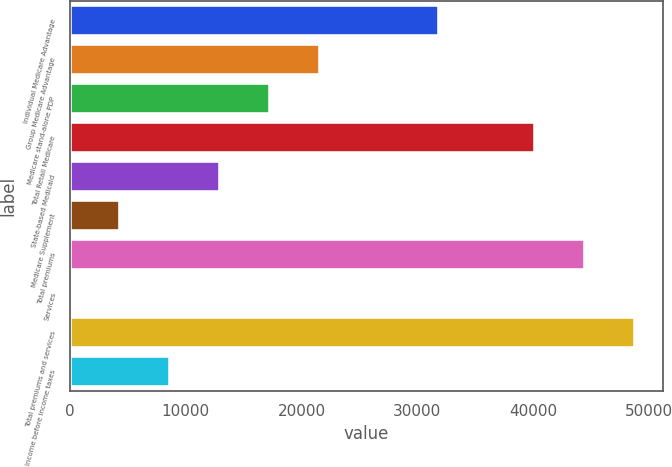Convert chart to OTSL. <chart><loc_0><loc_0><loc_500><loc_500><bar_chart><fcel>Individual Medicare Advantage<fcel>Group Medicare Advantage<fcel>Medicare stand-alone PDP<fcel>Total Retail Medicare<fcel>State-based Medicaid<fcel>Medicare Supplement<fcel>Total premiums<fcel>Services<fcel>Total premiums and services<fcel>Income before income taxes<nl><fcel>31863<fcel>21617.5<fcel>17295.2<fcel>40155<fcel>12972.9<fcel>4328.3<fcel>44477.3<fcel>6<fcel>48799.6<fcel>8650.6<nl></chart> 